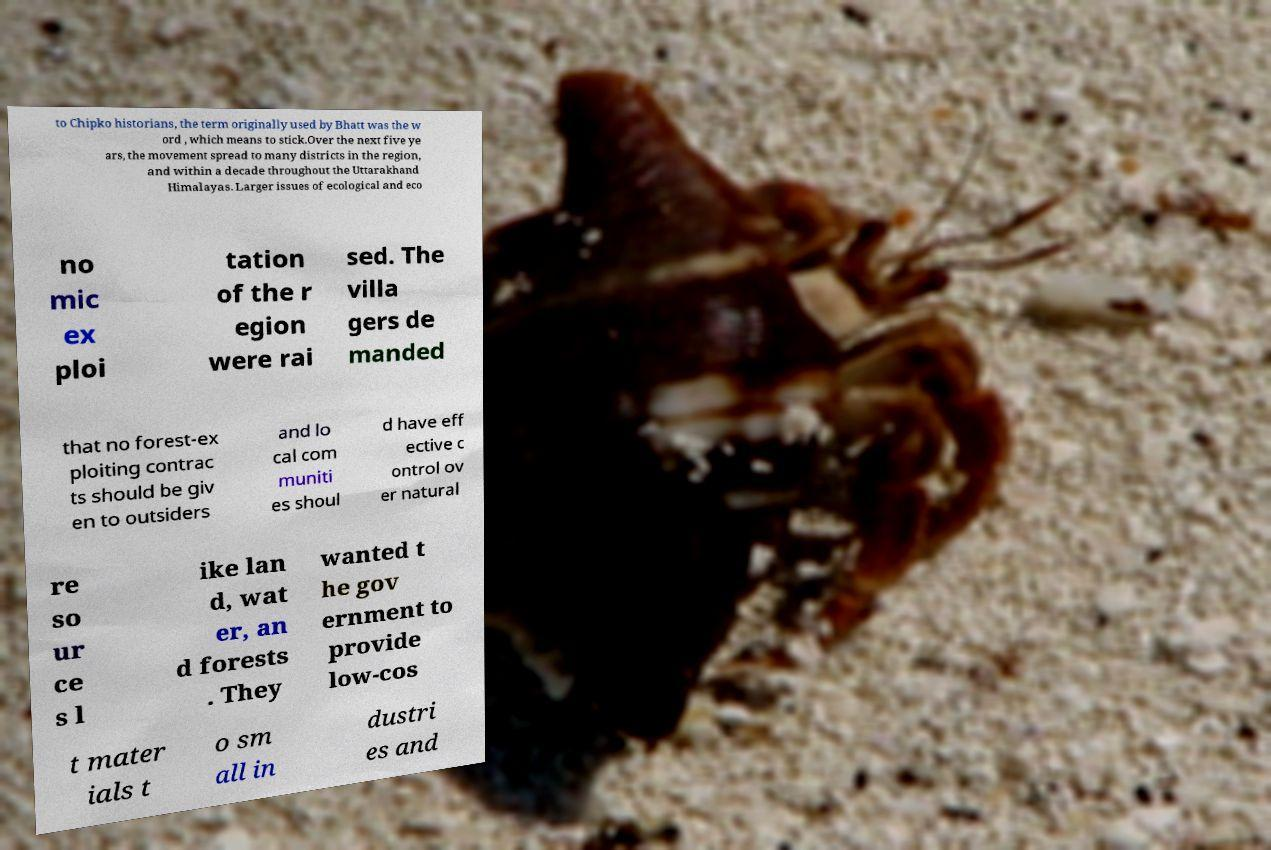Could you extract and type out the text from this image? to Chipko historians, the term originally used by Bhatt was the w ord , which means to stick.Over the next five ye ars, the movement spread to many districts in the region, and within a decade throughout the Uttarakhand Himalayas. Larger issues of ecological and eco no mic ex ploi tation of the r egion were rai sed. The villa gers de manded that no forest-ex ploiting contrac ts should be giv en to outsiders and lo cal com muniti es shoul d have eff ective c ontrol ov er natural re so ur ce s l ike lan d, wat er, an d forests . They wanted t he gov ernment to provide low-cos t mater ials t o sm all in dustri es and 